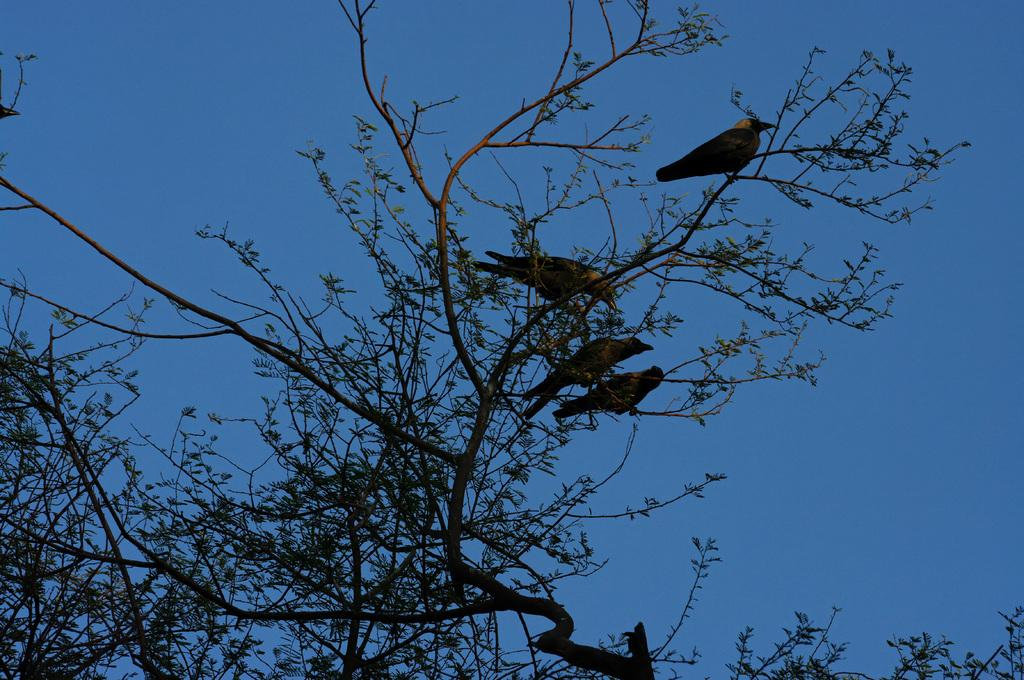What type of vegetation can be seen in the image? There are branches of trees in the image. What animals are on the branches? There are crows on the branches. What is visible in the background of the image? The sky is visible in the background of the image. What flavor of ice cream do the crows prefer in the image? There is no ice cream present in the image, and therefore no preference for flavor can be determined. 